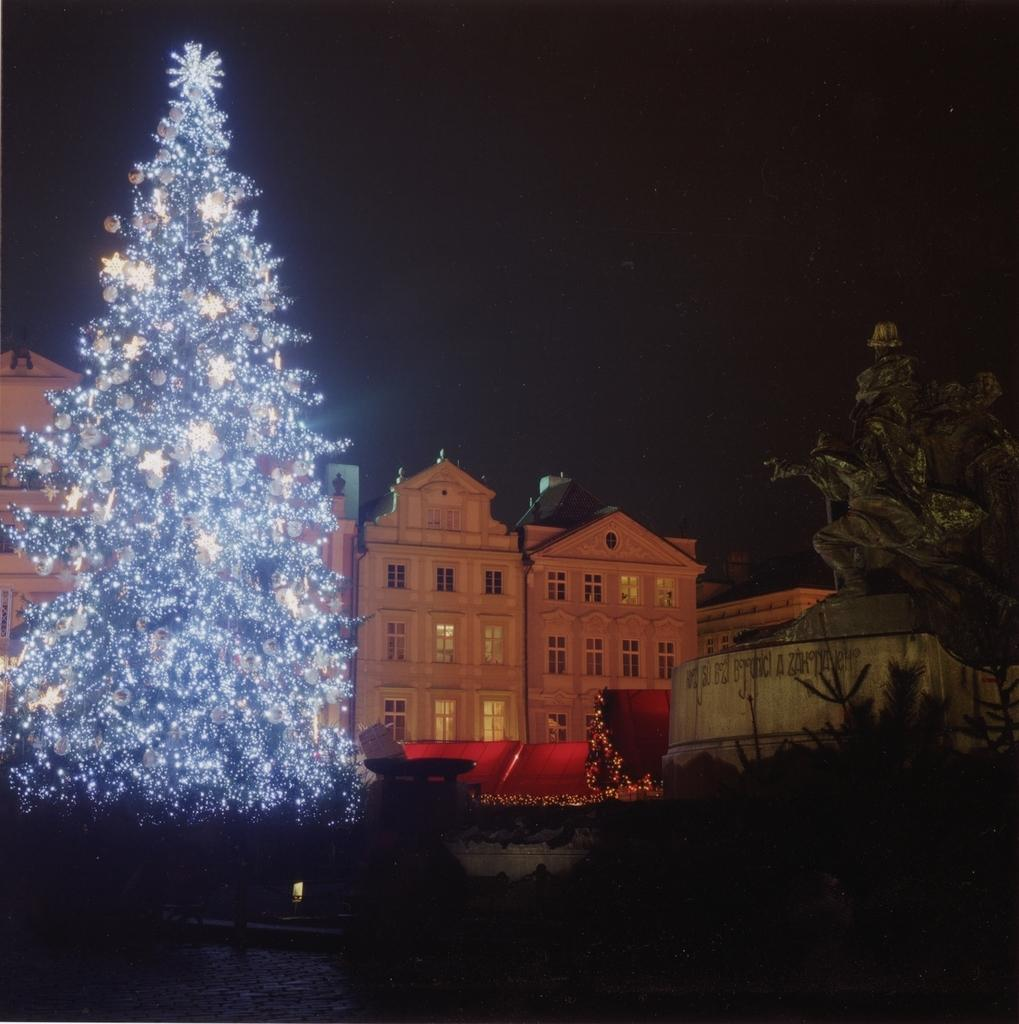What type of natural elements can be seen in the image? There are trees in the image. What type of man-made structures are present in the image? There are buildings in the image. What type of illumination is visible in the image? There are lights in the image. What type of sack is being carried by the sun in the image? There is no sun or sack present in the image. What type of journey is depicted in the image? The image does not depict a journey; it features trees, buildings, and lights. 